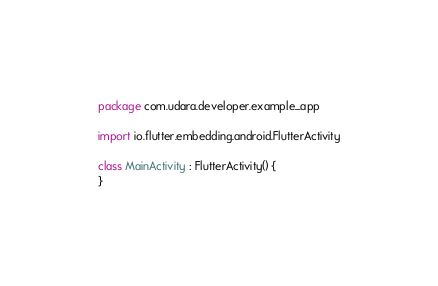<code> <loc_0><loc_0><loc_500><loc_500><_Kotlin_>package com.udara.developer.example_app

import io.flutter.embedding.android.FlutterActivity

class MainActivity : FlutterActivity() {
}
</code> 